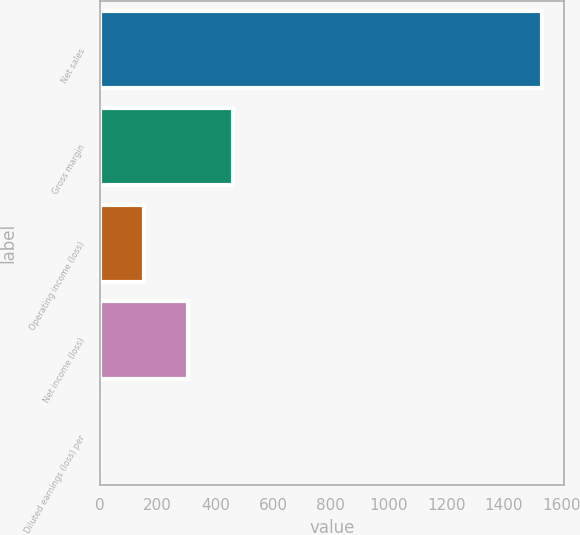<chart> <loc_0><loc_0><loc_500><loc_500><bar_chart><fcel>Net sales<fcel>Gross margin<fcel>Operating income (loss)<fcel>Net income (loss)<fcel>Diluted earnings (loss) per<nl><fcel>1530<fcel>459.11<fcel>153.13<fcel>306.12<fcel>0.15<nl></chart> 